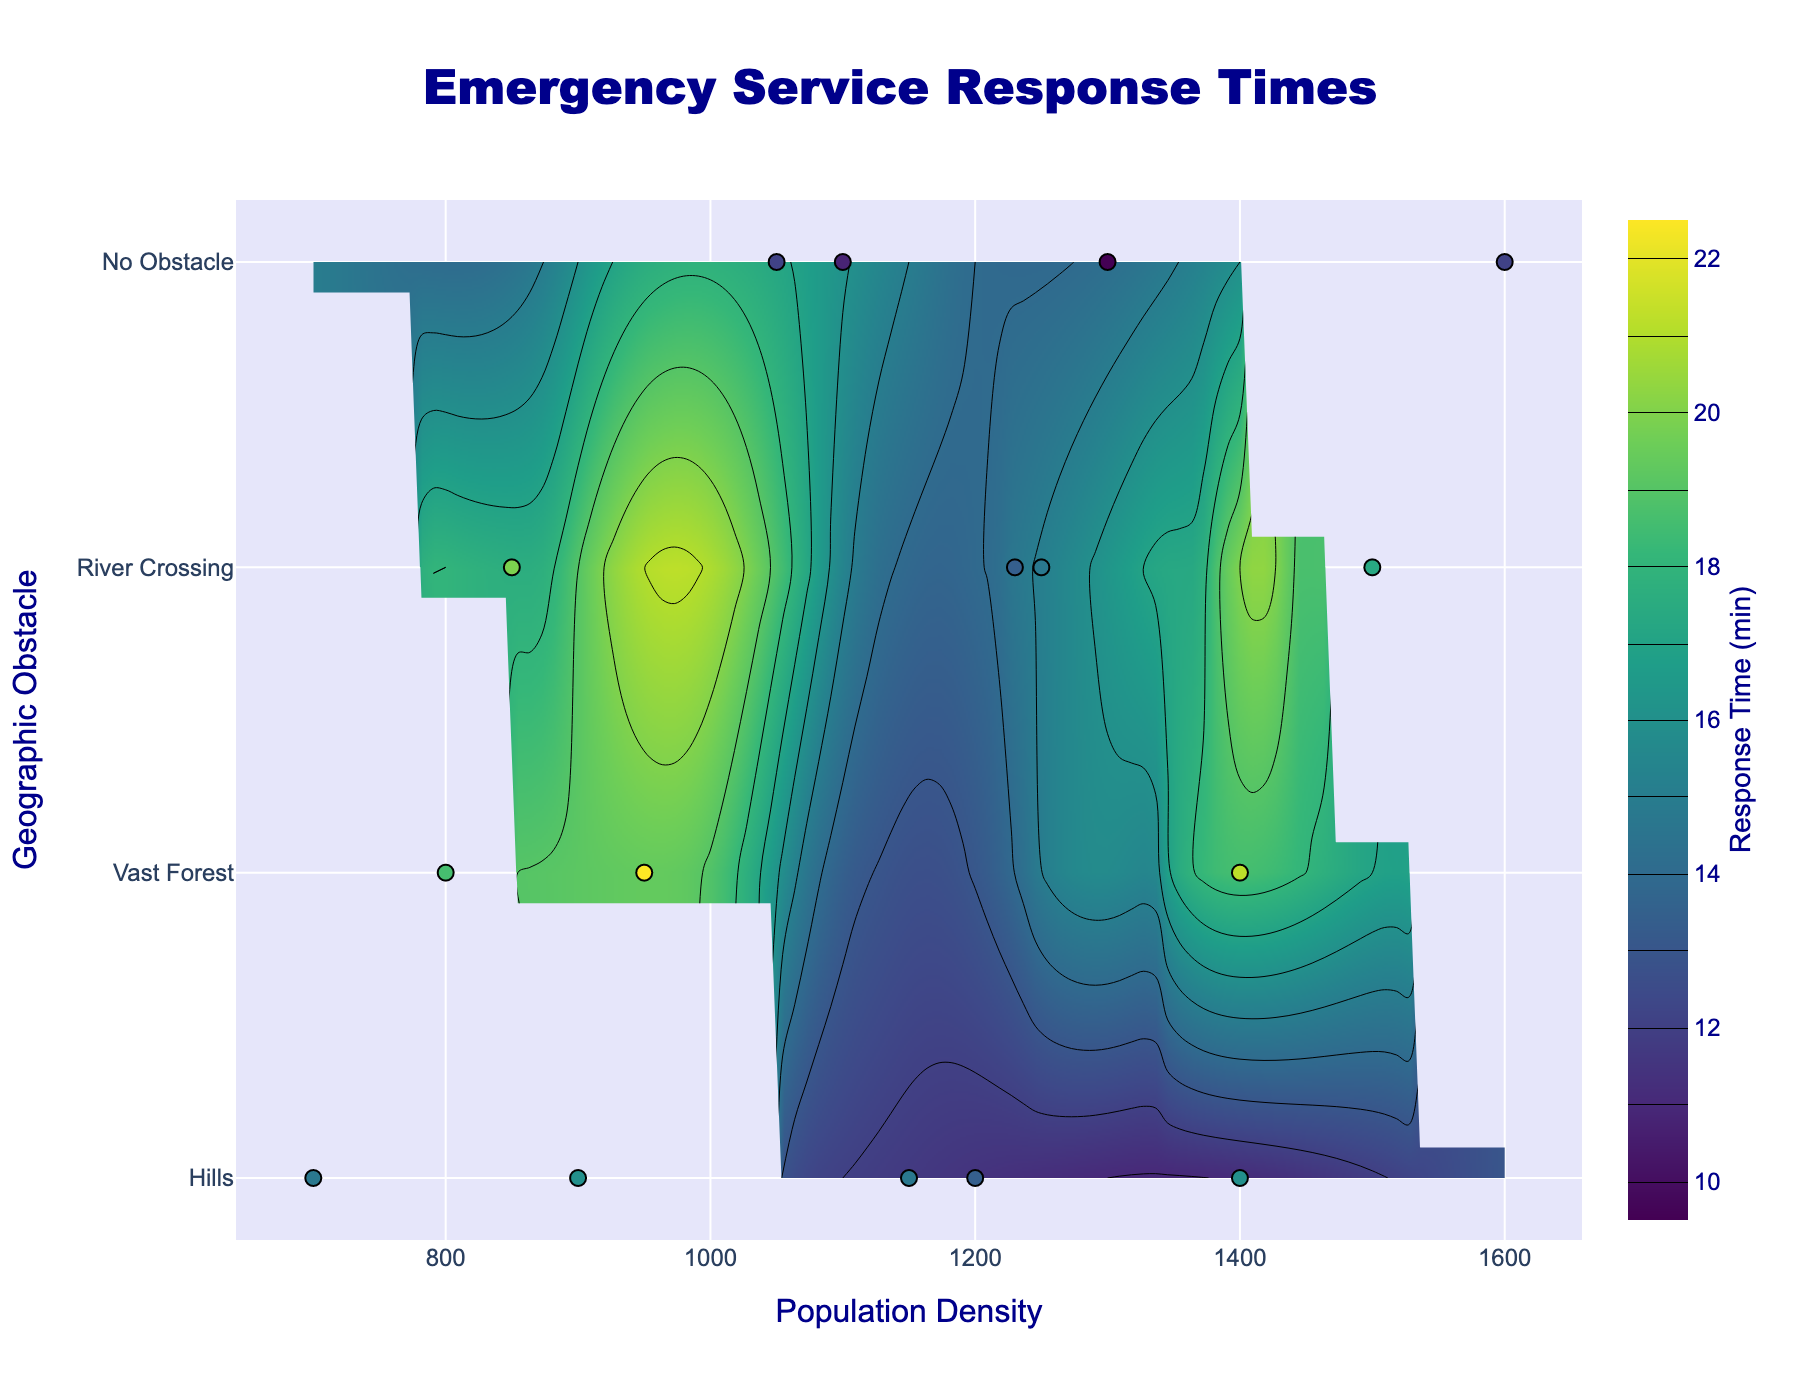What's the title of the figure? The title is located at the top center of the figure.
Answer: Emergency Service Response Times How many geographic obstacles are shown in the figure? The y-axis lists the different geographic obstacles. By counting them, we see there are four: Hills, Vast Forest, River Crossing, and No Obstacle.
Answer: 4 Which geographic obstacle has the highest response time for any population density? By visually inspecting the contour plot, the highest response times are shaded darker. The Vast Forest obstacle reaches up to 21 minutes, which is the highest.
Answer: Vast Forest What is the approximate response time for a population density of 1100 with no geographic obstacle? Locate the population density of 1100 on the x-axis and "No Obstacle" on the y-axis, then find the response time at this intersection. The contour lines and scatter plot indicate around 12 minutes.
Answer: 12 minutes Compare the response time for population densities of 1400 and 1600 with no obstacles. Which has a lower response time? Identify the 1400 and 1600 population densities on the x-axis under "No Obstacle" on the y-axis. The response times are around 11 and 13 minutes, respectively.
Answer: 1400 What's the response time difference between River Crossing and Hills for a population density of 900? Locate 900 on the x-axis and find "River Crossing" and "Hills" on the y-axis. The contour lines suggest 19 minutes for River Crossing and 16 minutes for Hills. The difference is 19 - 16 = 3 minutes.
Answer: 3 minutes For which population density range does the contour indicate the most significant increase in response times across all obstacles? Identify the steepest gradient in contour lines indicating a sharp increase. Between population densities 900 and 1250, there's a noticeable increase, especially in areas with geographic obstacles like River Crossing and Vast Forest.
Answer: 900 - 1250 What's the color scale used to indicate response times? The contour plot uses a color scale. By observing the legend, we see it uses shades interpreted by 'Viridis' ranging from light (lower response times) to dark (higher response times).
Answer: Viridis Which combination of population density and geographic obstacle is indicated to have the quickest response time? Identify the lightest color on the contour plot. The combination of a population density of around 1300 with no geographic obstacles shows about 11 minutes, the quickest time.
Answer: 1300, No Obstacle 